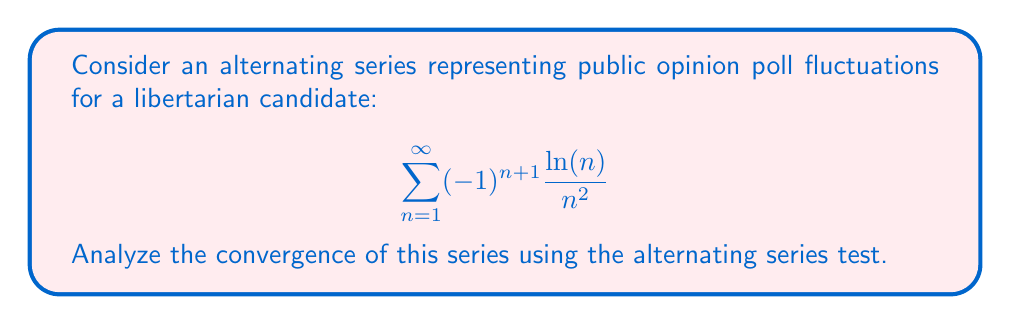Show me your answer to this math problem. To analyze the convergence of this alternating series, we'll use the alternating series test. For the series to converge, it must satisfy two conditions:

1. The absolute value of the general term must approach zero as n approaches infinity:
   $$\lim_{n \to \infty} \left|\frac{\ln(n)}{n^2}\right| = 0$$

2. The absolute value of the general term must be monotonically decreasing for all n greater than some N.

Let's check these conditions:

1. Limit condition:
   $$\lim_{n \to \infty} \left|\frac{\ln(n)}{n^2}\right| = \lim_{n \to \infty} \frac{\ln(n)}{n^2}$$
   
   Using L'Hôpital's rule twice:
   $$\lim_{n \to \infty} \frac{\ln(n)}{n^2} = \lim_{n \to \infty} \frac{1/n}{2n} = \lim_{n \to \infty} \frac{1}{2n^2} = 0$$

   The limit condition is satisfied.

2. Monotonically decreasing condition:
   Let $a_n = \frac{\ln(n)}{n^2}$. We need to show that $a_{n+1} < a_n$ for all n greater than some N.
   
   $$\frac{a_{n+1}}{a_n} = \frac{\ln(n+1)}{(n+1)^2} \cdot \frac{n^2}{\ln(n)} = \frac{n^2 \ln(n+1)}{(n+1)^2 \ln(n)}$$
   
   As n increases, this ratio approaches 1 from below, meaning $a_{n+1} < a_n$ for sufficiently large n.

Since both conditions are satisfied, the alternating series converges by the alternating series test.
Answer: The series converges. 